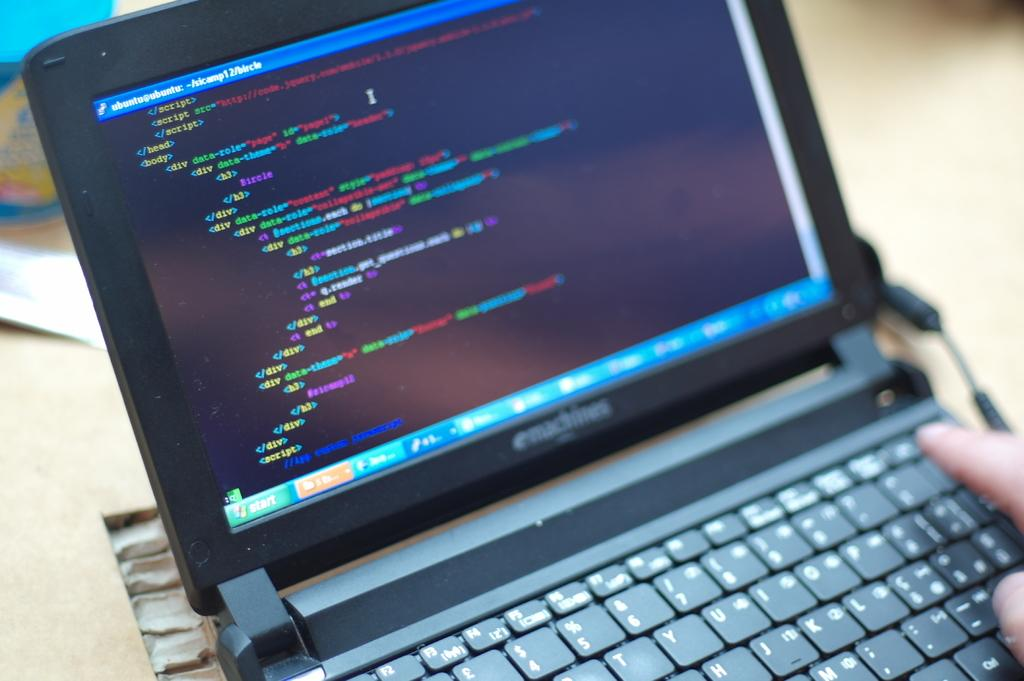<image>
Offer a succinct explanation of the picture presented. Person using an emachines laptop that says ubuntu at the top. 